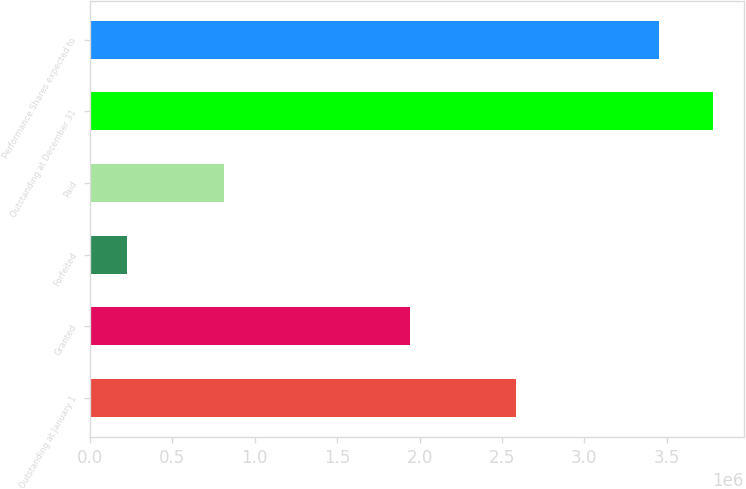Convert chart. <chart><loc_0><loc_0><loc_500><loc_500><bar_chart><fcel>Outstanding at January 1<fcel>Granted<fcel>Forfeited<fcel>Paid<fcel>Outstanding at December 31<fcel>Performance Shares expected to<nl><fcel>2.58665e+06<fcel>1.9443e+06<fcel>224538<fcel>812975<fcel>3.77892e+06<fcel>3.45203e+06<nl></chart> 